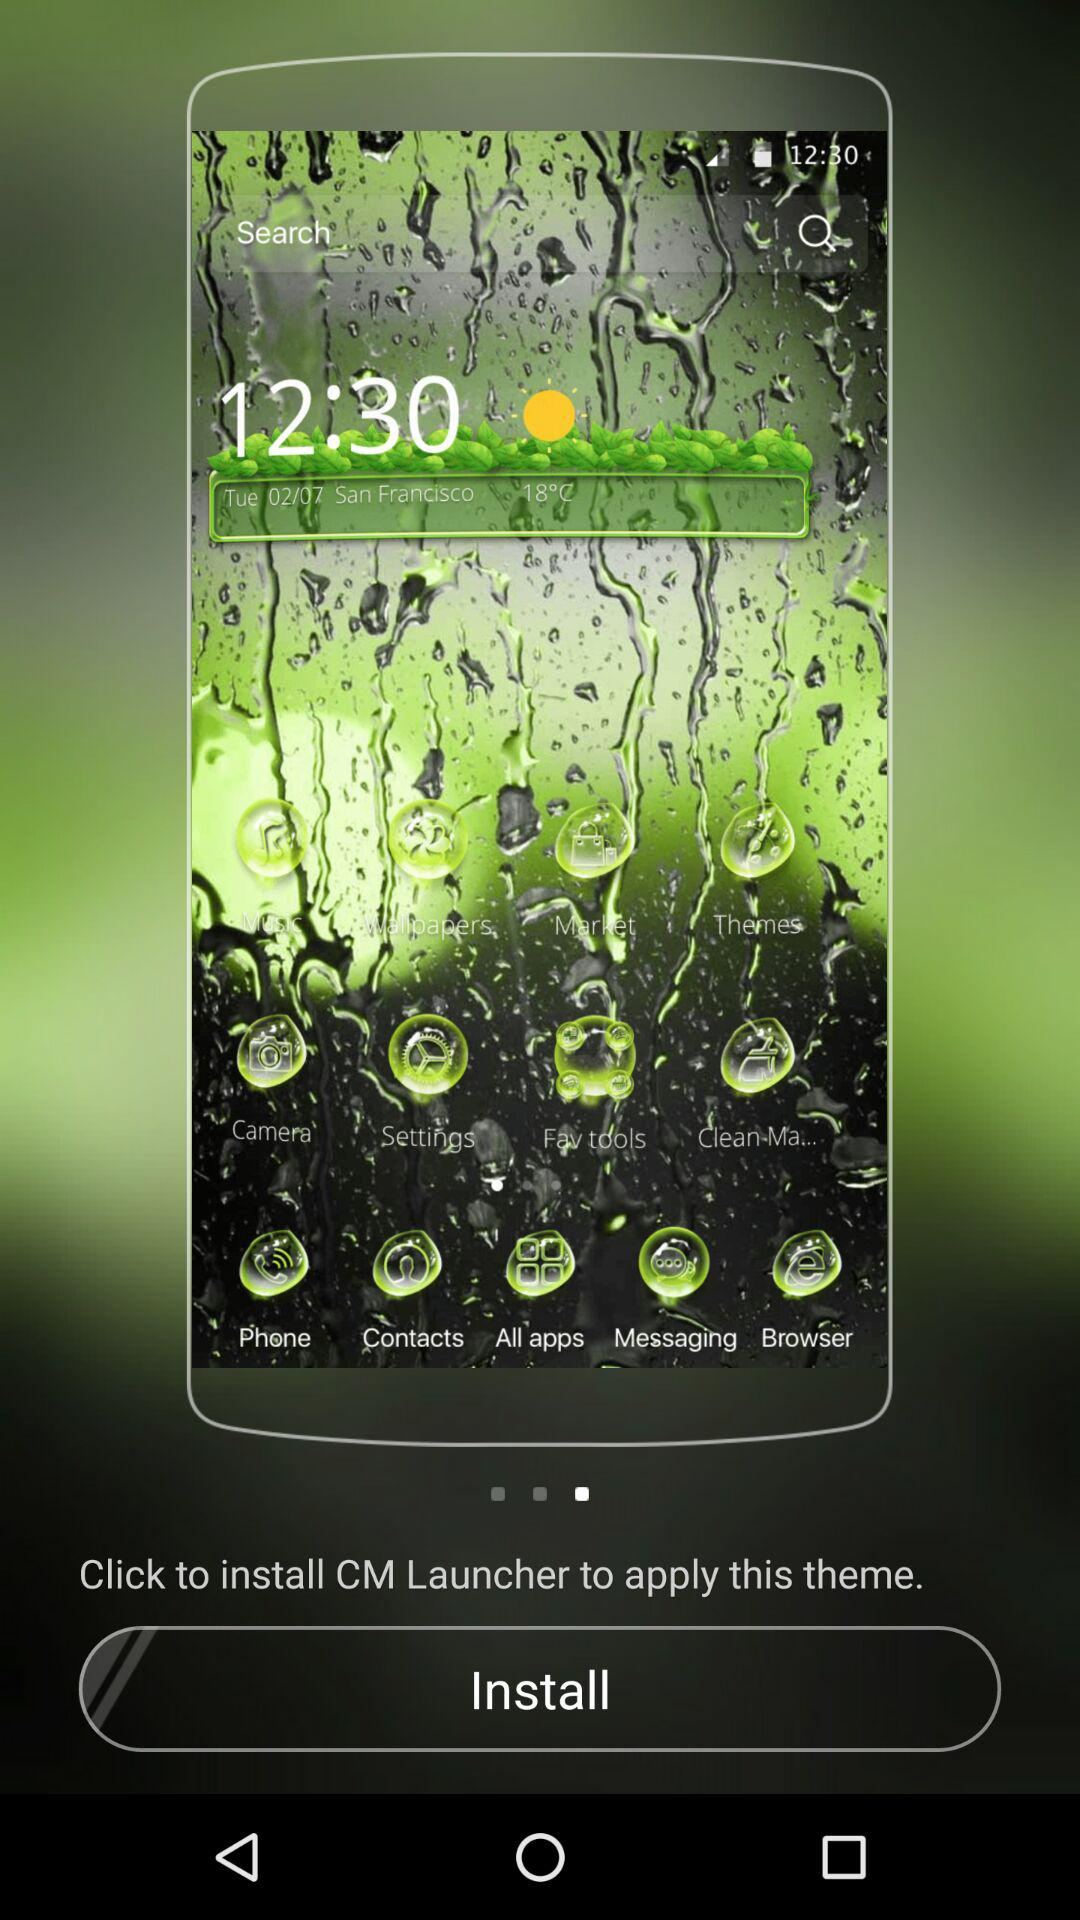What is to be installed to apply the theme? The application "CM Launcher" is to be installed to apply the theme. 